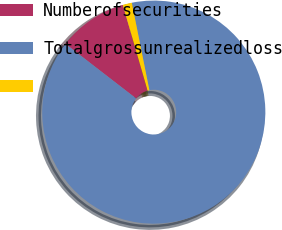<chart> <loc_0><loc_0><loc_500><loc_500><pie_chart><fcel>Numberofsecurities<fcel>Totalgrossunrealizedloss<fcel>Unnamed: 2<nl><fcel>10.05%<fcel>88.63%<fcel>1.32%<nl></chart> 